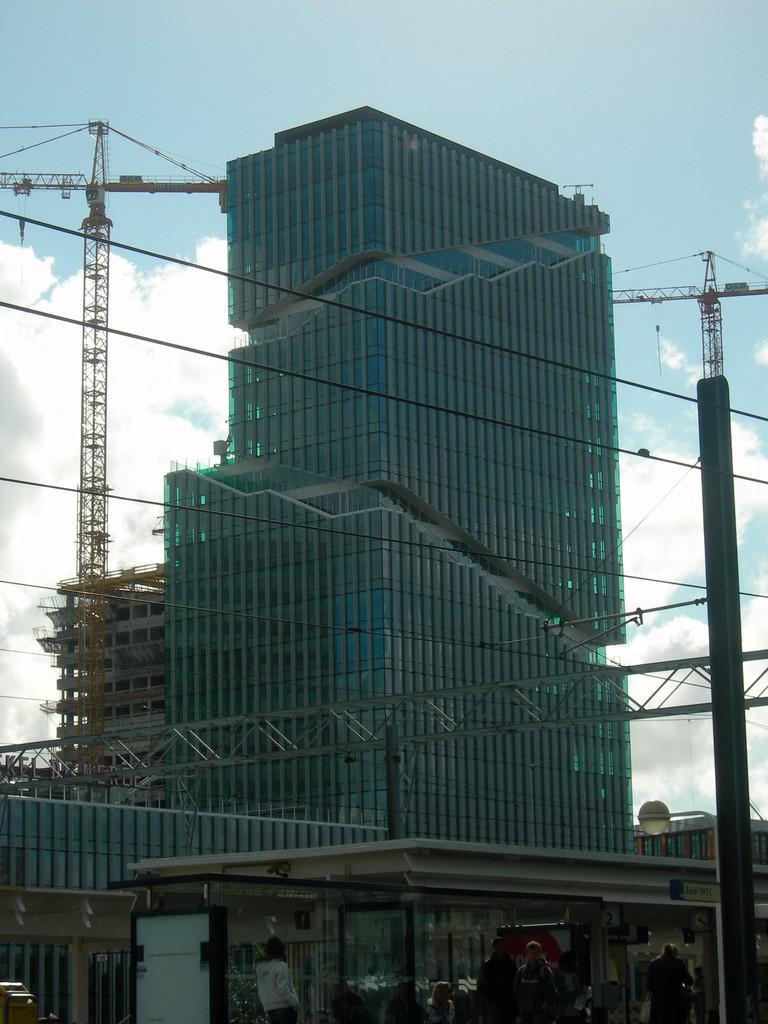Describe this image in one or two sentences. In this image we can see a building, crane, sky, clouds. At the bottom of the image there are people. 